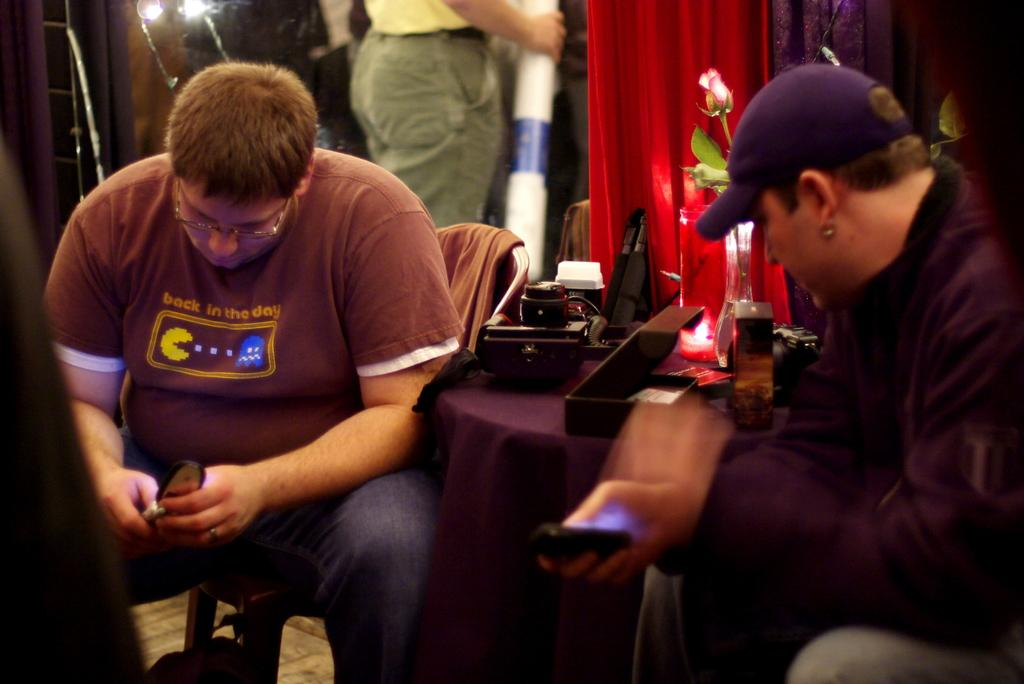How many men are in the image? There are two men in the image. What are the men holding in their hands? The men are holding mobiles in their hands. Can you describe the background of the image? In the background of the image, there is a person, clothes, a flowers vase, a chair, a box, and some other objects. What might be the purpose of the chair in the background? The chair in the background might be for sitting or placing items on. What type of objects can be seen in the background? Some objects in the background include a flowers vase, a box, and other unspecified items. What type of mint can be seen growing in the image? There is no mint present in the image. What is the men's reaction to the fear in the image? There is no fear depicted in the image, and the men's reactions cannot be determined. 